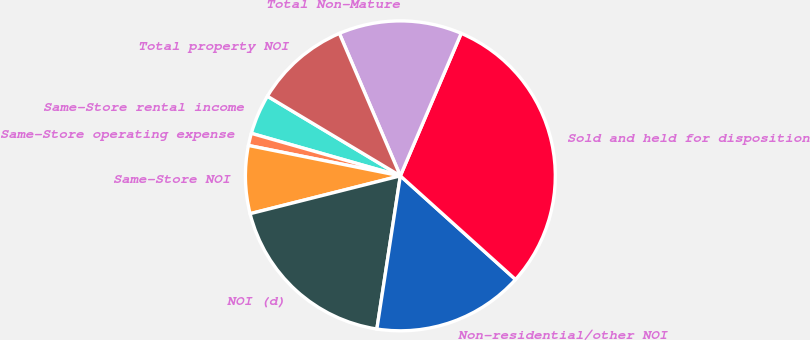Convert chart to OTSL. <chart><loc_0><loc_0><loc_500><loc_500><pie_chart><fcel>Same-Store rental income<fcel>Same-Store operating expense<fcel>Same-Store NOI<fcel>NOI (d)<fcel>Non-residential/other NOI<fcel>Sold and held for disposition<fcel>Total Non-Mature<fcel>Total property NOI<nl><fcel>4.17%<fcel>1.28%<fcel>7.07%<fcel>18.65%<fcel>15.76%<fcel>30.24%<fcel>12.86%<fcel>9.97%<nl></chart> 